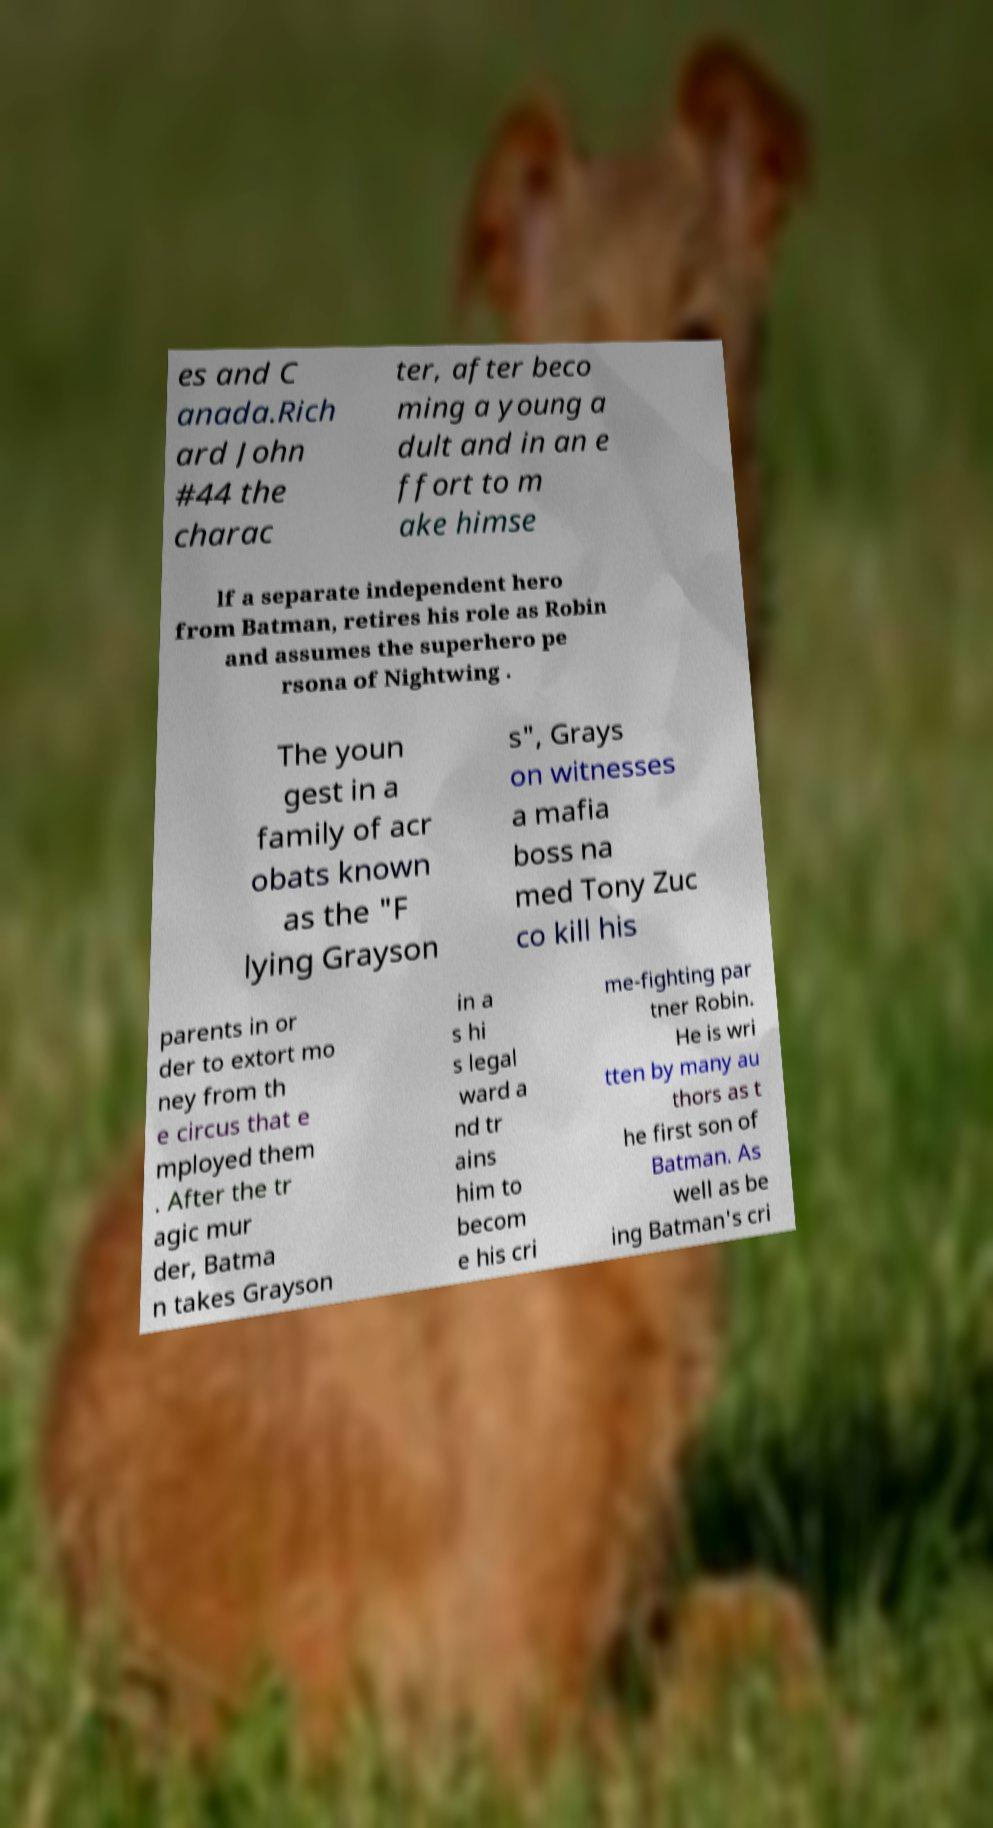Can you read and provide the text displayed in the image?This photo seems to have some interesting text. Can you extract and type it out for me? es and C anada.Rich ard John #44 the charac ter, after beco ming a young a dult and in an e ffort to m ake himse lf a separate independent hero from Batman, retires his role as Robin and assumes the superhero pe rsona of Nightwing . The youn gest in a family of acr obats known as the "F lying Grayson s", Grays on witnesses a mafia boss na med Tony Zuc co kill his parents in or der to extort mo ney from th e circus that e mployed them . After the tr agic mur der, Batma n takes Grayson in a s hi s legal ward a nd tr ains him to becom e his cri me-fighting par tner Robin. He is wri tten by many au thors as t he first son of Batman. As well as be ing Batman's cri 